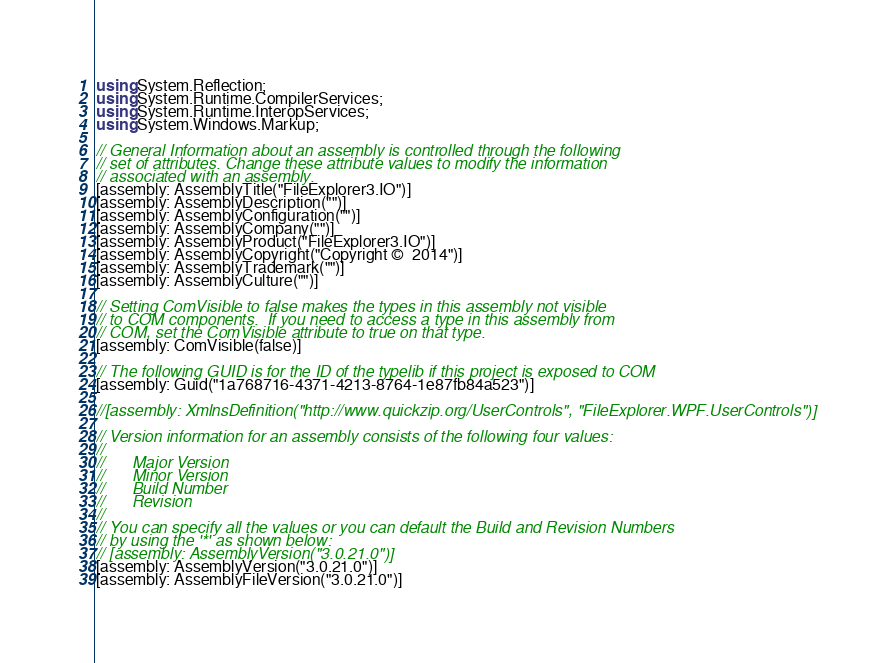Convert code to text. <code><loc_0><loc_0><loc_500><loc_500><_C#_>using System.Reflection;
using System.Runtime.CompilerServices;
using System.Runtime.InteropServices;
using System.Windows.Markup;

// General Information about an assembly is controlled through the following 
// set of attributes. Change these attribute values to modify the information
// associated with an assembly.
[assembly: AssemblyTitle("FileExplorer3.IO")]
[assembly: AssemblyDescription("")]
[assembly: AssemblyConfiguration("")]
[assembly: AssemblyCompany("")]
[assembly: AssemblyProduct("FileExplorer3.IO")]
[assembly: AssemblyCopyright("Copyright ©  2014")]
[assembly: AssemblyTrademark("")]
[assembly: AssemblyCulture("")]

// Setting ComVisible to false makes the types in this assembly not visible 
// to COM components.  If you need to access a type in this assembly from 
// COM, set the ComVisible attribute to true on that type.
[assembly: ComVisible(false)]

// The following GUID is for the ID of the typelib if this project is exposed to COM
[assembly: Guid("1a768716-4371-4213-8764-1e87fb84a523")]

//[assembly: XmlnsDefinition("http://www.quickzip.org/UserControls", "FileExplorer.WPF.UserControls")]

// Version information for an assembly consists of the following four values:
//
//      Major Version
//      Minor Version 
//      Build Number
//      Revision
//
// You can specify all the values or you can default the Build and Revision Numbers 
// by using the '*' as shown below:
// [assembly: AssemblyVersion("3.0.21.0")]
[assembly: AssemblyVersion("3.0.21.0")]
[assembly: AssemblyFileVersion("3.0.21.0")]
</code> 